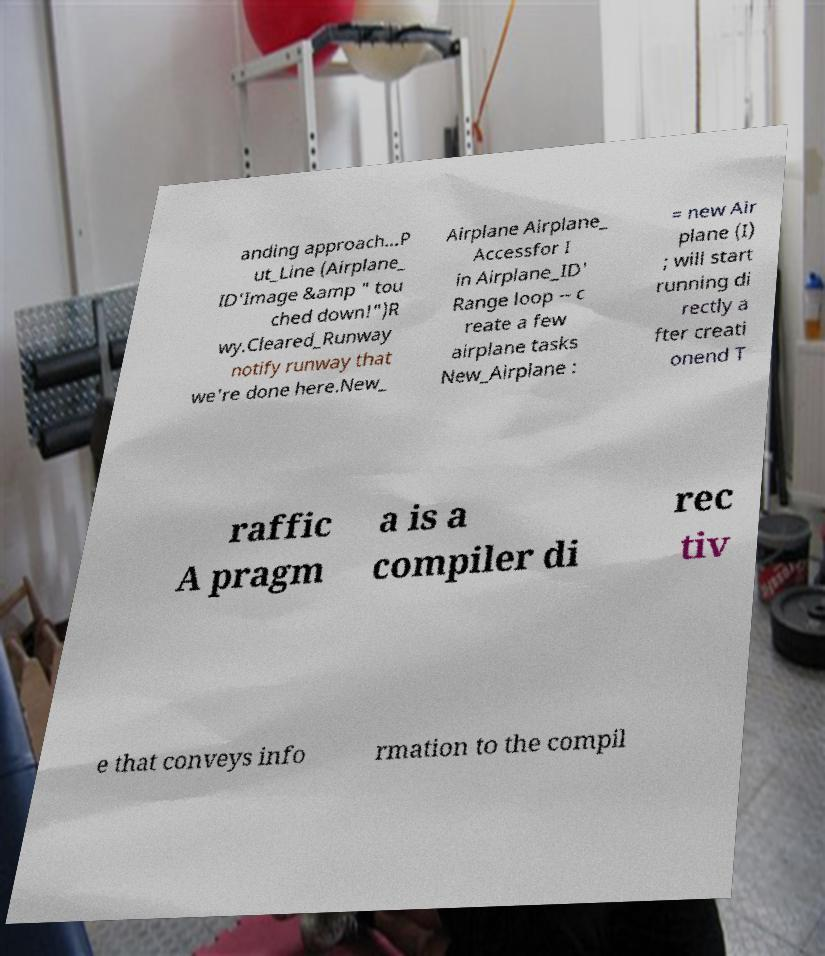Could you extract and type out the text from this image? anding approach...P ut_Line (Airplane_ ID'Image &amp " tou ched down!")R wy.Cleared_Runway notify runway that we're done here.New_ Airplane Airplane_ Accessfor I in Airplane_ID' Range loop -- c reate a few airplane tasks New_Airplane : = new Air plane (I) ; will start running di rectly a fter creati onend T raffic A pragm a is a compiler di rec tiv e that conveys info rmation to the compil 